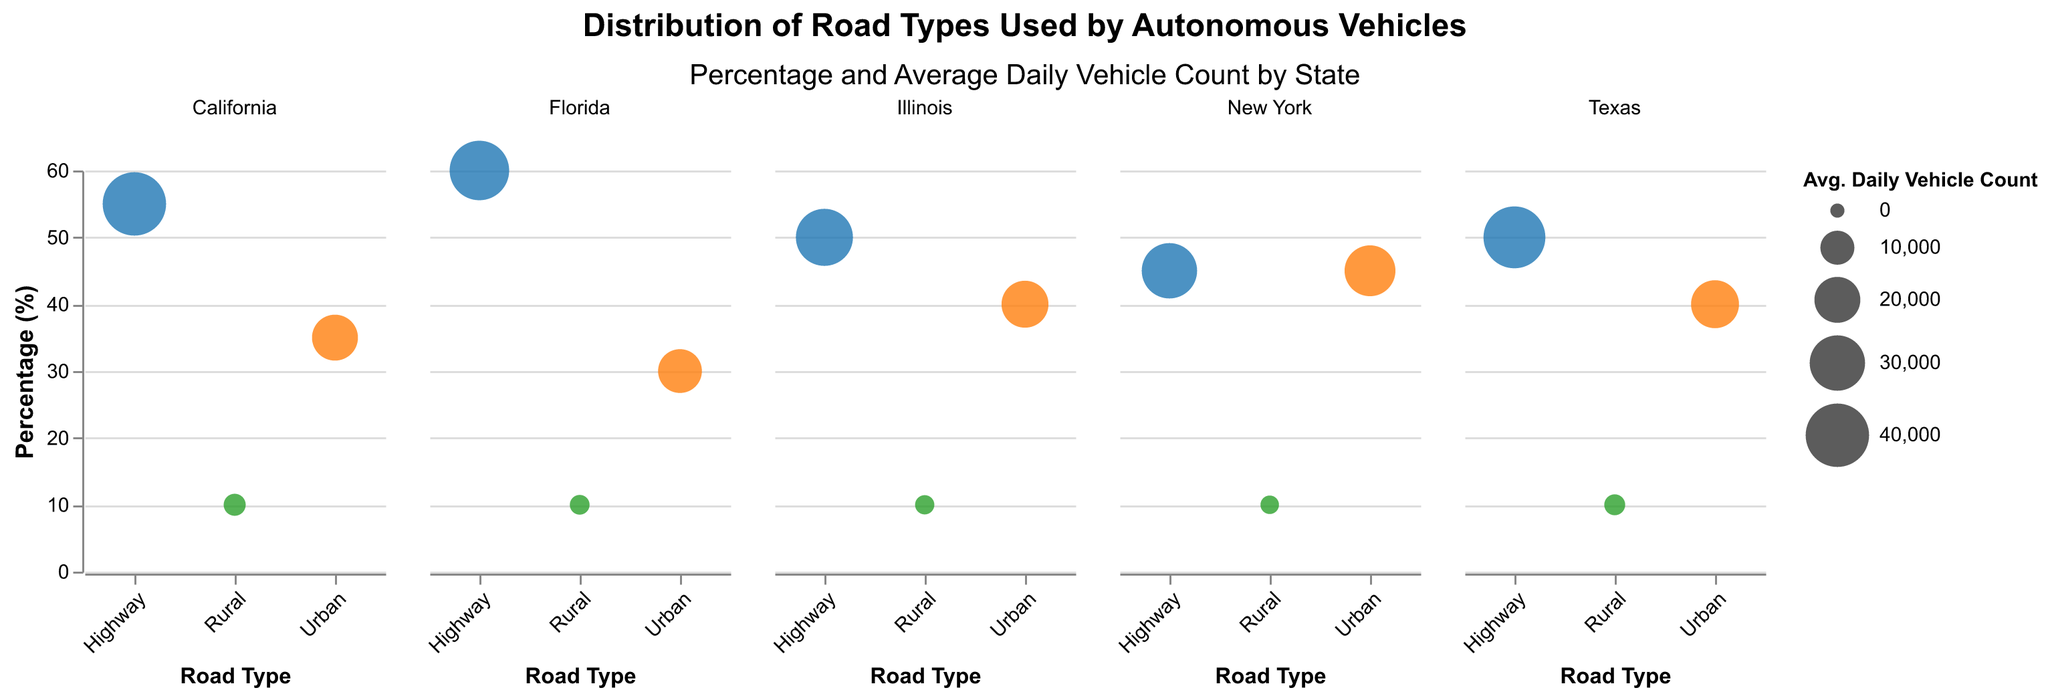what are the road types represented in the chart? The road types are indicated by different colors in the legend and are labeled on the x-axis. They are "Highway," "Urban," and "Rural."
Answer: Highway, Urban, Rural Which state has the highest percentage of highway use? Among the states listed, Florida has the highest percentage of highway use, which is indicated by the height of the bubble in the 'Highway' column of the Florida subplot.
Answer: Florida What is the average daily vehicle count for urban roads in New York? The bubble size for the 'Urban' road type in the New York subplot represents the average daily vehicle count, and hovering over it in the interactive chart shows this value.
Answer: 25,000 How does the percentage of urban road use in Texas compare to that in Illinois? For Texas, the percentage of urban road use is 40%, whereas for Illinois, it is also 40%. The chart shows two bubbles of equal height in the 'Urban' column for these two states.
Answer: They are equal Which road type has the smallest average daily vehicle count in all states? By examining the bubble sizes for all three road types across all state subplots, it is evident that rural roads consistently have the smallest average daily vehicle count.
Answer: Rural What's the percentage difference in highway use between California and New York? The highway usage percentages for California and New York are 55% and 45%, respectively. The difference is computed by subtracting New York's percentage from California's percentage: 55% - 45% = 10%.
Answer: 10% Which state has the lowest percentage of urban road use and what is that percentage? The state with the lowest urban road use percentage is Florida at 30%, as indicated by the height of the bubble in the 'Urban' column of the Florida subplot.
Answer: Florida, 30% What proportion of road use in California is on rural roads compared to urban roads? In California, rural road use is 10%, and urban road use is 35%. The proportion of rural to urban road use can be computed by dividing 10 by 35, resulting in approximately 0.286.
Answer: 0.286 How does the average daily vehicle count for highways in Texas compare to that in Illinois? The bubble size for the 'Highway' road type in Texas represents 38,000 vehicles, while in Illinois, it represents 32,000 vehicles. Thus, Texas has a higher count.
Answer: Texas has a higher count 